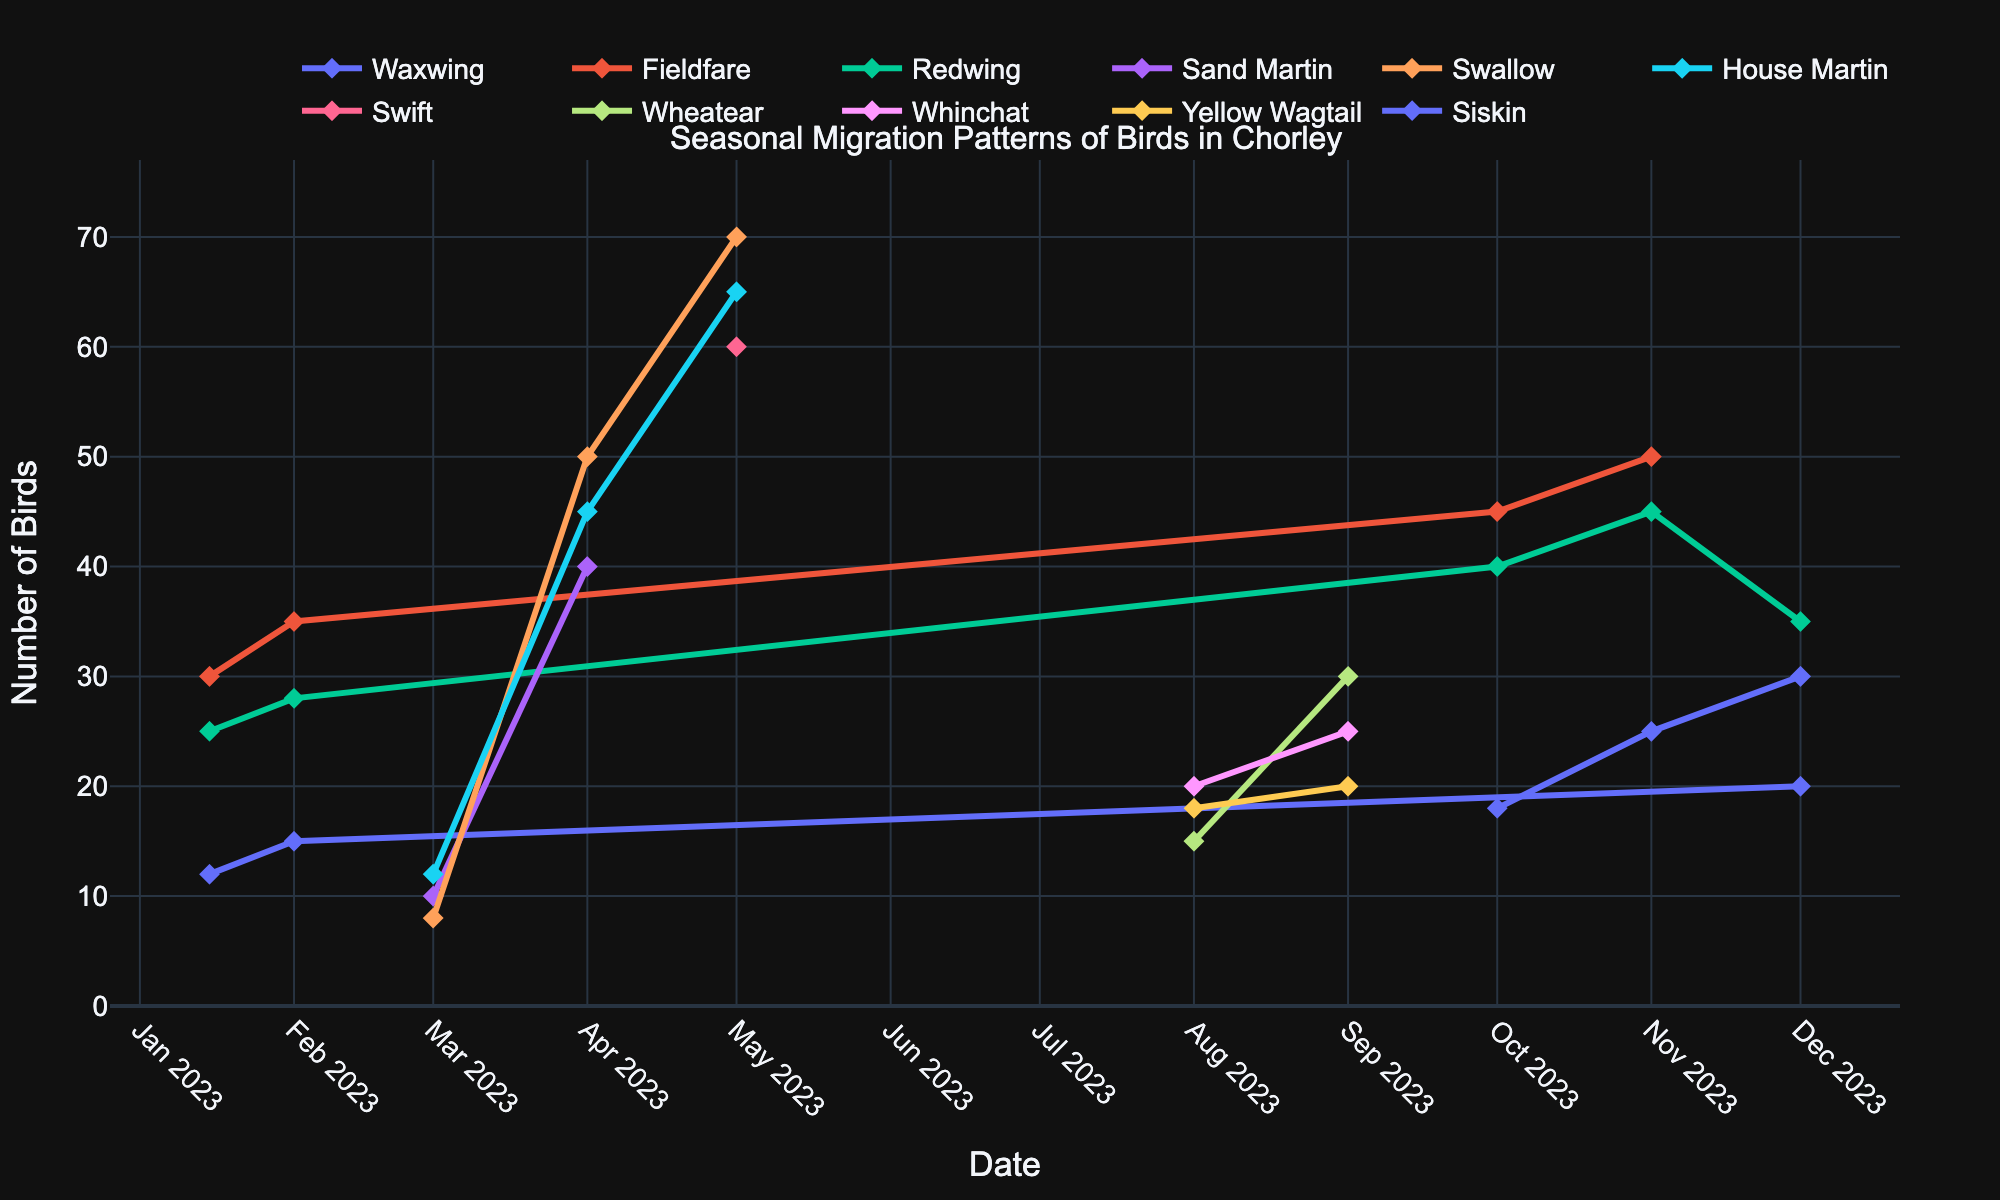What is the title of the plot? The title is shown at the top of the plot. It is "Seasonal Migration Patterns of Birds in Chorley".
Answer: Seasonal Migration Patterns of Birds in Chorley Which month had the highest number of Swallows observed? Look at the line representing Swallows and identify the month with the highest y-value (number of birds). April has the highest at around 50 birds.
Answer: April How many Fieldfares were observed in November? Locate the data point for Fieldfares in November on the x-axis and read the y-value. There were 50 Fieldfares observed.
Answer: 50 In which months were Waxwings observed? List them all. Look for the points on the plot representing Waxwings and identify their corresponding x-axis (months). Waxwings were observed in January, February, and December.
Answer: January, February, December What is the total number of birds observed for all species in March? Sum the number of birds for Sand Martin, Swallow, and House Martin in March: 10 (Sand Martin) + 8 (Swallow) + 12 (House Martin) = 30.
Answer: 30 Did the number of Yellow Wagtails increase or decrease from August to September? Compare the y-values for Yellow Wagtail in August and September. The number increased from 18 in August to 20 in September.
Answer: Increase Which species had the highest observation in May? Check the y-values for all species in May and identify the highest one. Swallows were the highest with 70 birds.
Answer: Swallow How many species are shown in the plot? Count the number of unique species represented. There are Waxwing, Fieldfare, Redwing, Sand Martin, Swallow, House Martin, Swift, Wheatear, Whinchat, Yellow Wagtail, and Siskin, totaling 11 species.
Answer: 11 Which month had the highest overall bird count across all species? Sum the number of birds for all species in each month and determine which month has the highest total. In May: Swift (60) + Swallow (70) + House Martin (65) = 195, the highest total.
Answer: May What is the difference between the number of Waxwings observed in January and December? Identify the y-values for Waxwings in January (12) and December (20), then compute the difference: 20 - 12 = 8.
Answer: 8 